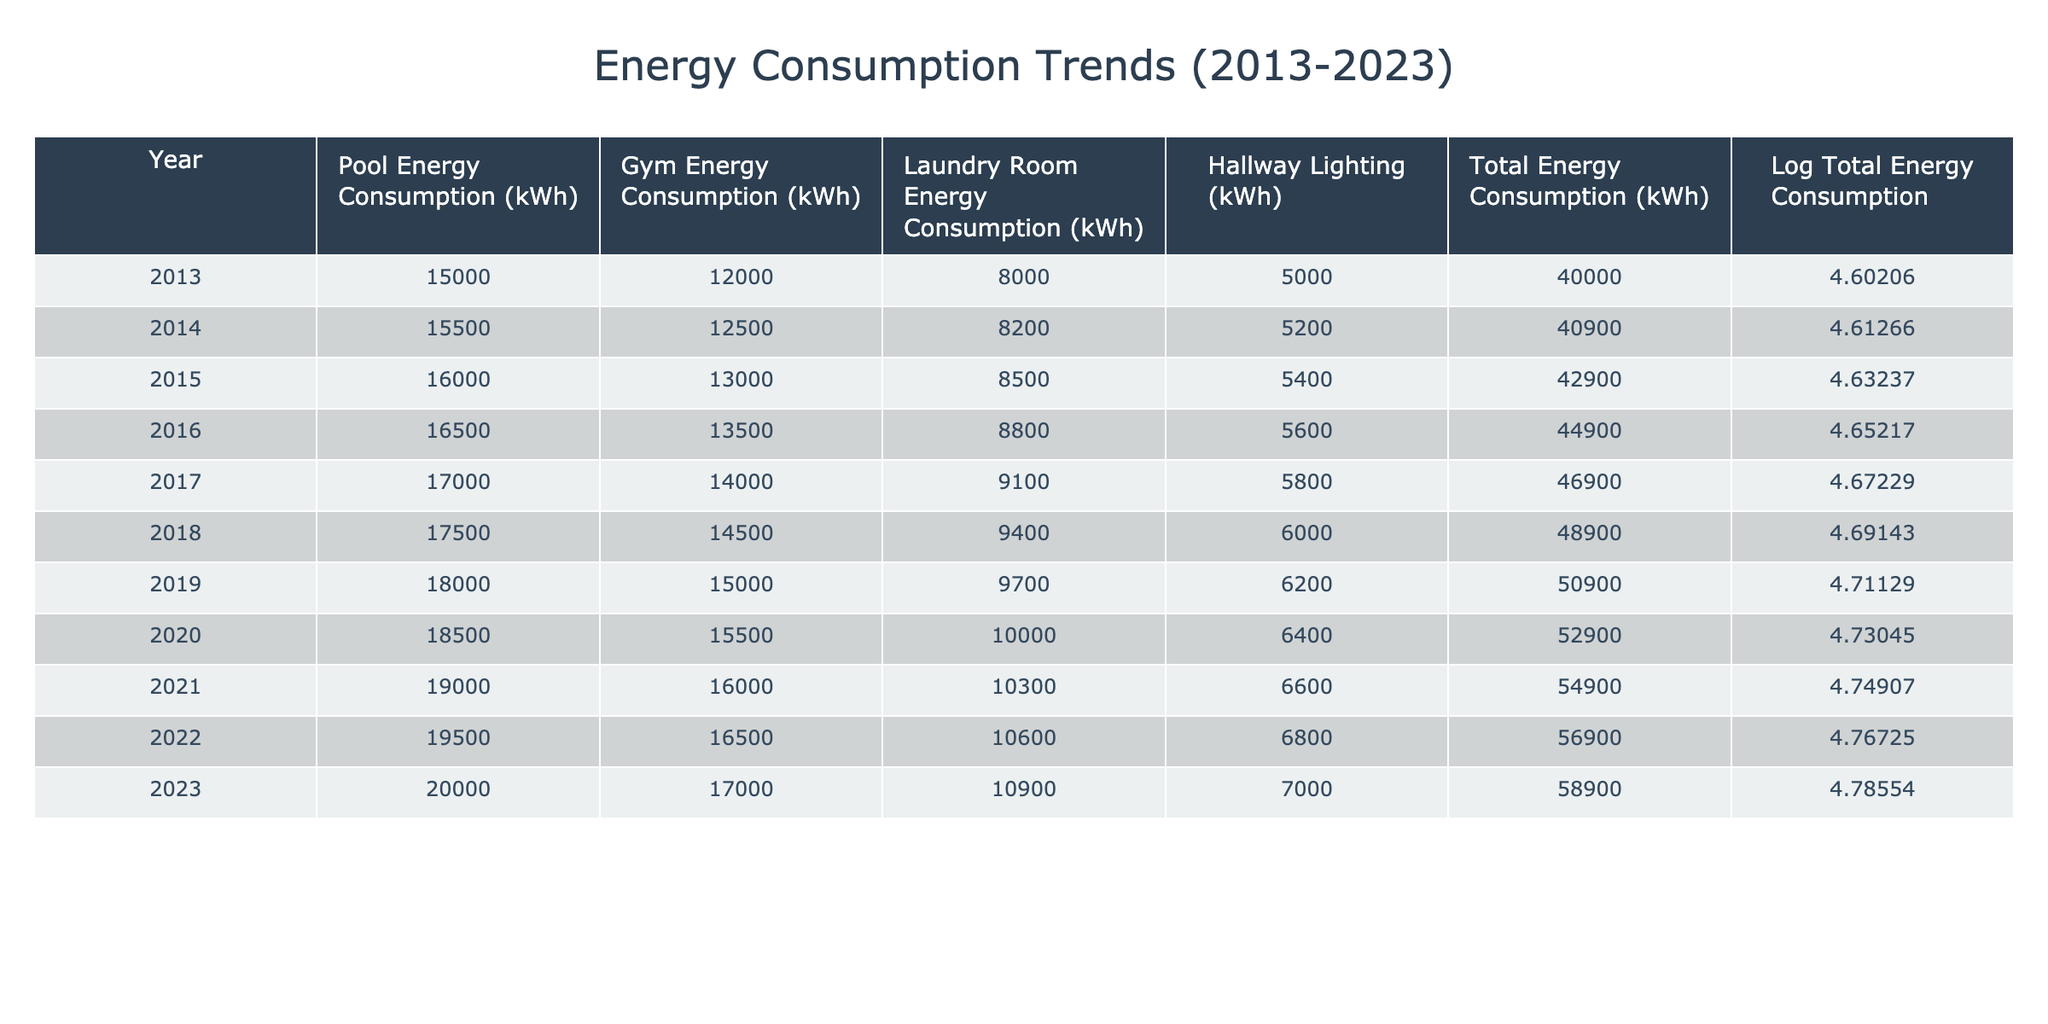What was the total energy consumption in 2016? The table shows the total energy consumption for each year. In 2016, the total energy consumption is listed as 44900 kWh.
Answer: 44900 kWh What is the logarithmic value of total energy consumption for 2022? The table includes a column for logarithmic values of total energy consumption. For the year 2022, the value is 4.76725.
Answer: 4.76725 Which year had the highest total energy consumption? By scanning through the total energy consumption values, it can be observed that 2023 has the highest total energy consumption listed, which is 58900 kWh.
Answer: 2023 What is the average energy consumption of the Gym from 2013 to 2023? To find the average, first, we need to sum the Gym energy consumption values from each year: (12000 + 12500 + 13000 + 13500 + 14000 + 14500 + 15000 + 15500 + 16000 + 17000) = 141500 kWh. Then, we divide by the number of years (10), which gives us 141500 / 10 = 14150 kWh.
Answer: 14150 kWh Did the energy consumption for the Pool increase every year? By examining the Pool energy consumption values, we can see that they consistently increase each year from 15000 kWh in 2013 to 20000 kWh in 2023, confirming that the consumption did indeed increase every year.
Answer: Yes What was the increase in total energy consumption from 2019 to 2023? The total energy consumption in 2019 was 50900 kWh, and in 2023 it was 58900 kWh. The increase can be calculated by subtracting the earlier value from the later value: 58900 - 50900 = 8000 kWh.
Answer: 8000 kWh 